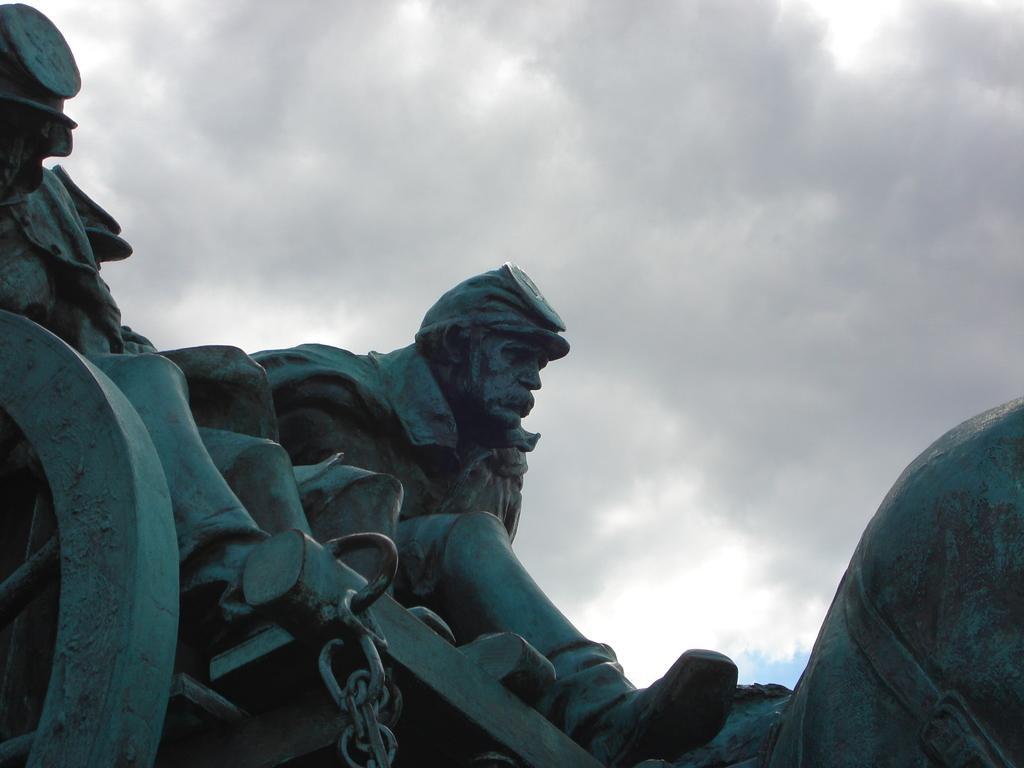Please provide a concise description of this image. In this picture we can observe a statue of a person. There is another person's statue on the left side, sitting in the chariot. We can observe a wheel. In the background there is a sky with clouds. 